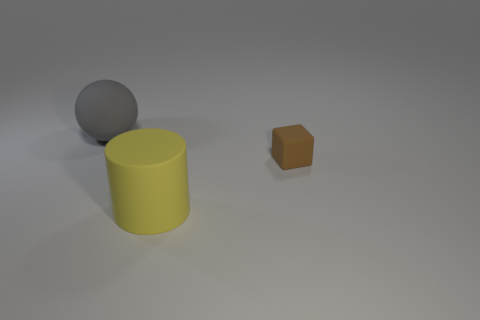Add 3 small red cubes. How many objects exist? 6 Subtract all gray balls. How many green cylinders are left? 0 Subtract all large green balls. Subtract all large matte spheres. How many objects are left? 2 Add 1 objects. How many objects are left? 4 Add 1 gray rubber objects. How many gray rubber objects exist? 2 Subtract 0 green balls. How many objects are left? 3 Subtract all blue balls. Subtract all purple cubes. How many balls are left? 1 